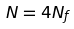<formula> <loc_0><loc_0><loc_500><loc_500>N = 4 N _ { f }</formula> 